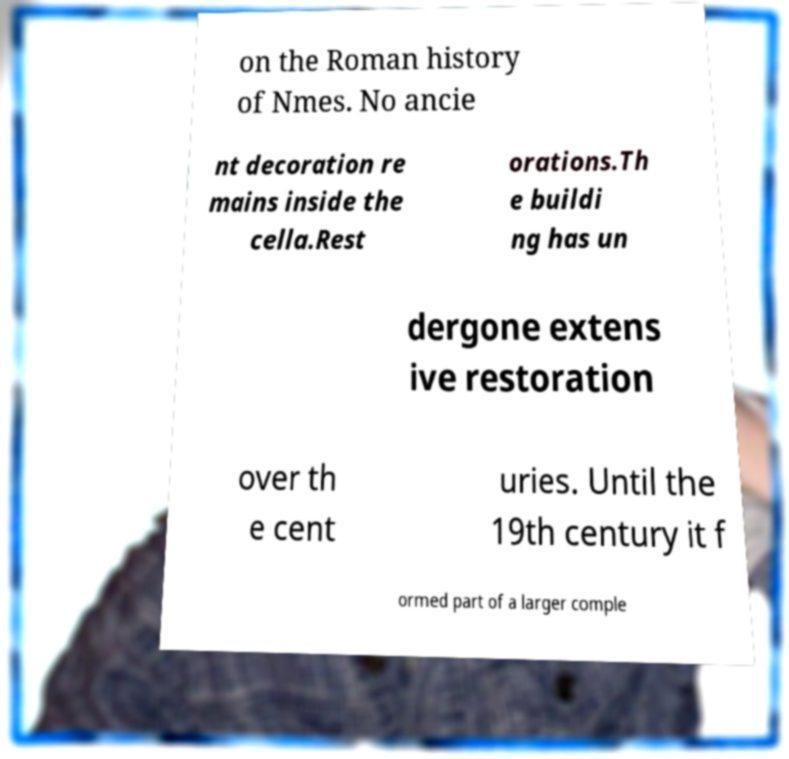Please read and relay the text visible in this image. What does it say? on the Roman history of Nmes. No ancie nt decoration re mains inside the cella.Rest orations.Th e buildi ng has un dergone extens ive restoration over th e cent uries. Until the 19th century it f ormed part of a larger comple 